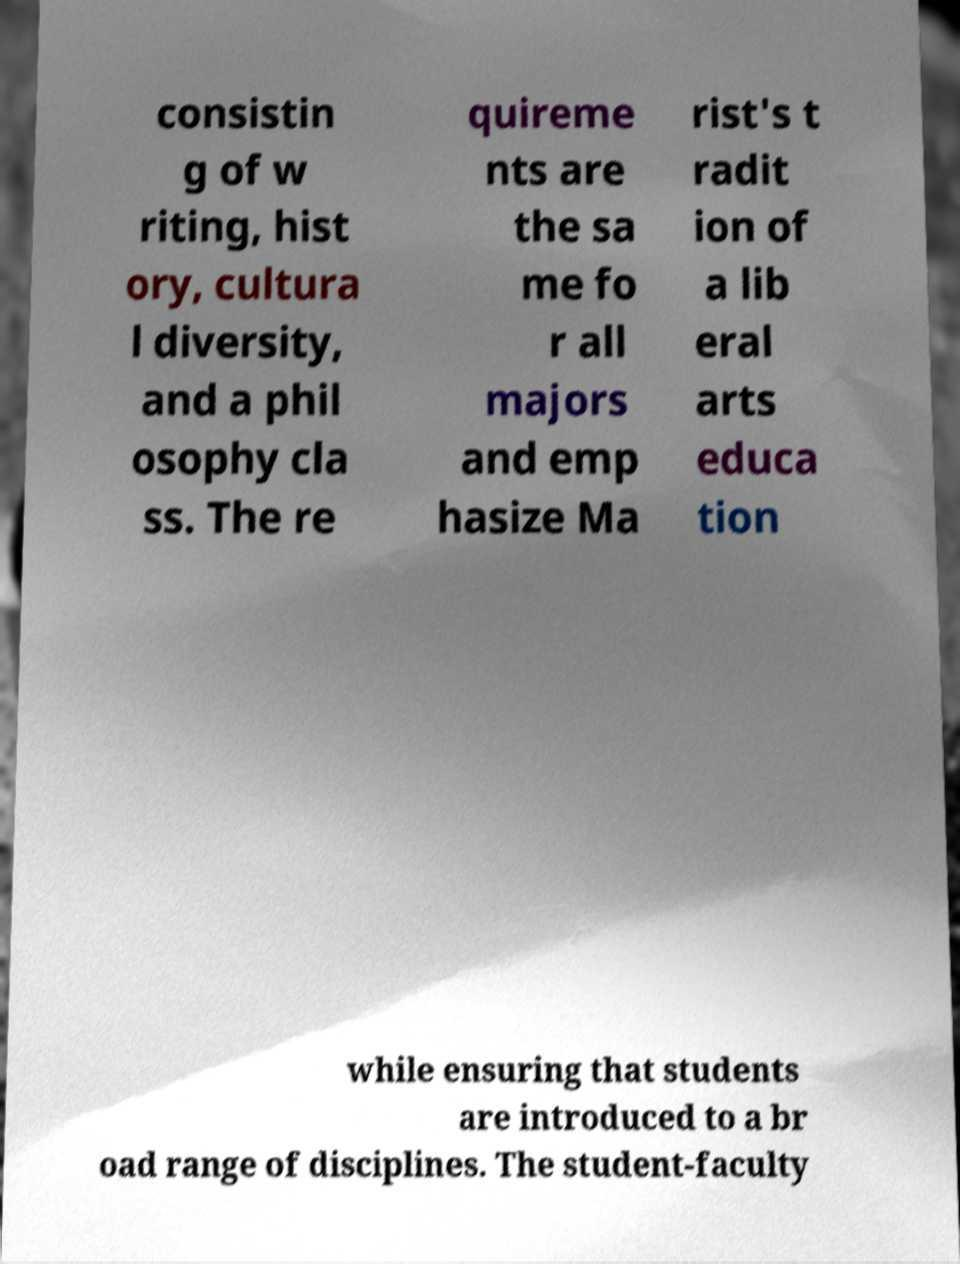Please identify and transcribe the text found in this image. consistin g of w riting, hist ory, cultura l diversity, and a phil osophy cla ss. The re quireme nts are the sa me fo r all majors and emp hasize Ma rist's t radit ion of a lib eral arts educa tion while ensuring that students are introduced to a br oad range of disciplines. The student-faculty 